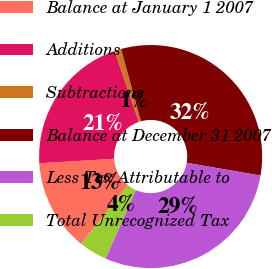<chart> <loc_0><loc_0><loc_500><loc_500><pie_chart><fcel>Balance at January 1 2007<fcel>Additions<fcel>Subtractions<fcel>Balance at December 31 2007<fcel>Less Tax Attributable to<fcel>Total Unrecognized Tax<nl><fcel>13.36%<fcel>20.74%<fcel>0.95%<fcel>32.0%<fcel>28.9%<fcel>4.05%<nl></chart> 